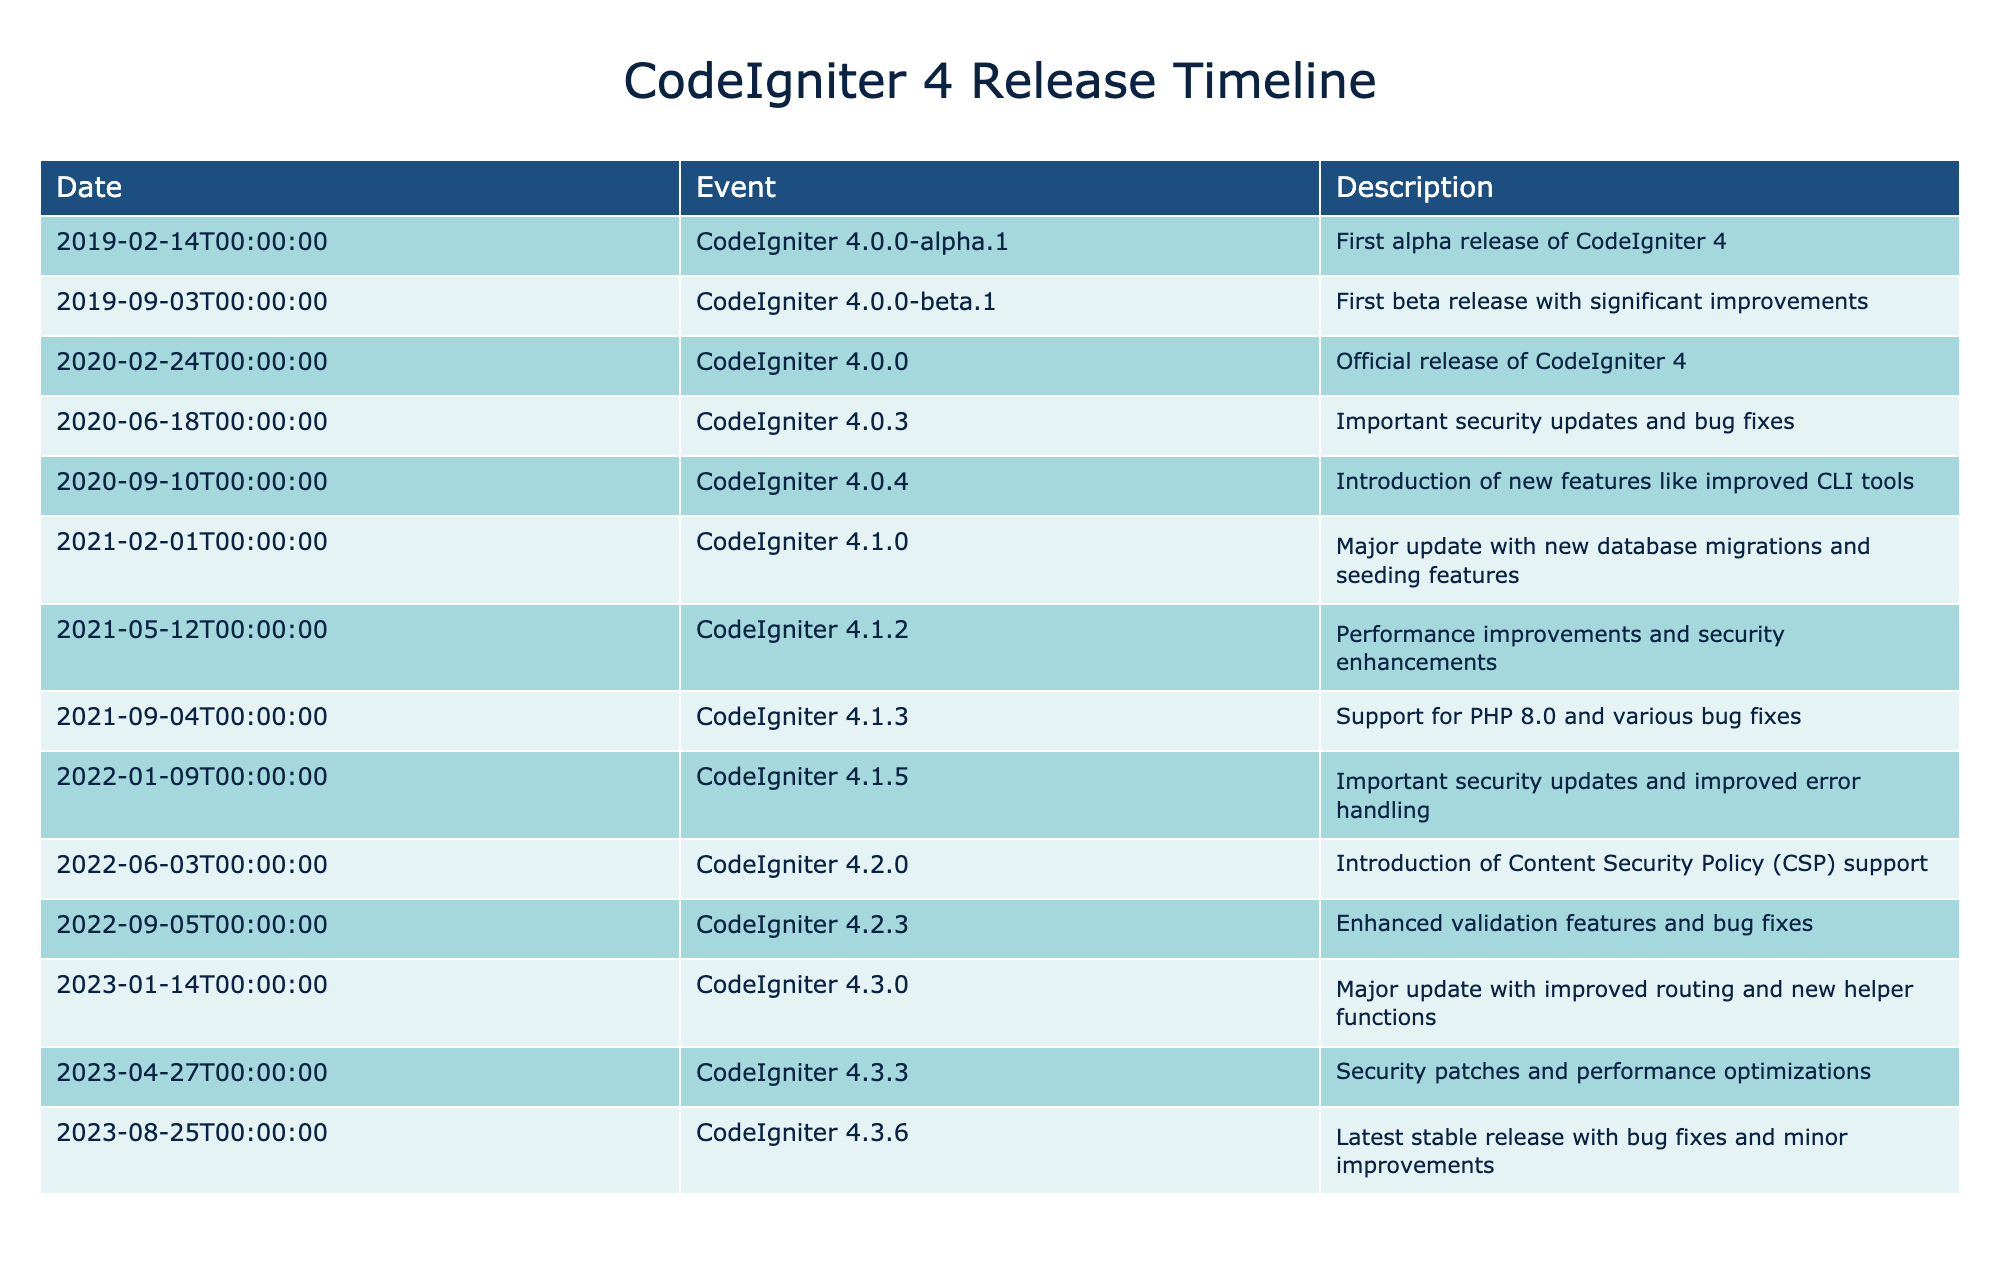What is the date of the first alpha release of CodeIgniter 4? The table lists the events chronologically. The first event is "CodeIgniter 4.0.0-alpha.1," which has a date of February 14, 2019.
Answer: February 14, 2019 Which version introduced support for PHP 8.0? Looking at the table, "CodeIgniter 4.1.3" was released on September 4, 2021, and it specifically mentions support for PHP 8.0.
Answer: CodeIgniter 4.1.3 How many total releases occurred in 2022? There are two entries in 2022: "CodeIgniter 4.2.0" on June 3 and "CodeIgniter 4.2.3" on September 5. Therefore, adding these gives a total of 2 releases in that year.
Answer: 2 Did any version of CodeIgniter 4 release major updates in 2021? Based on the table, there are two noted versions in 2021 that are significant: "CodeIgniter 4.1.0," which brought major updates with new database migrations and seeding features, and "CodeIgniter 4.1.2," which included performance improvements and security enhancements. Thus, the answer is yes; there were major updates.
Answer: Yes What improvements were included in the latest stable release? The last event in the table is "CodeIgniter 4.3.6," which released on August 25, 2023. It mentions bug fixes and minor improvements as part of its updates.
Answer: Bug fixes and minor improvements What is the average time span between releases from CodeIgniter 4.0.0 to CodeIgniter 4.3.6? To calculate the average span, we take the dates of the first release (February 14, 2019) and the last (August 25, 2023). This gives about 4 years and 6 months or approximately 54 months. There were 12 releases from the beginning to the end, thus the average span is 54 months divided by 12, resulting in approximately 4.5 months per release.
Answer: 4.5 months What are the security-focused releases from the table? By carefully scanning the events, we find that the following entries mention security updates: "CodeIgniter 4.0.3" on June 18, 2020; "CodeIgniter 4.1.5" on January 9, 2022; and "CodeIgniter 4.3.3" on April 27, 2023. Therefore, there are three distinct releases focused on security.
Answer: 3 Which release introduced Content Security Policy support? The entry "CodeIgniter 4.2.0" on June 3, 2022, explicitly states that it introduced Content Security Policy support.
Answer: CodeIgniter 4.2.0 Was there a version released in 2020 that included new features for CLI tools? The table notes that "CodeIgniter 4.0.4," released on September 10, 2020, introduced new features, specifically mentioning improved CLI tools. Therefore, yes, a version meeting this criteria was released in that year.
Answer: Yes 